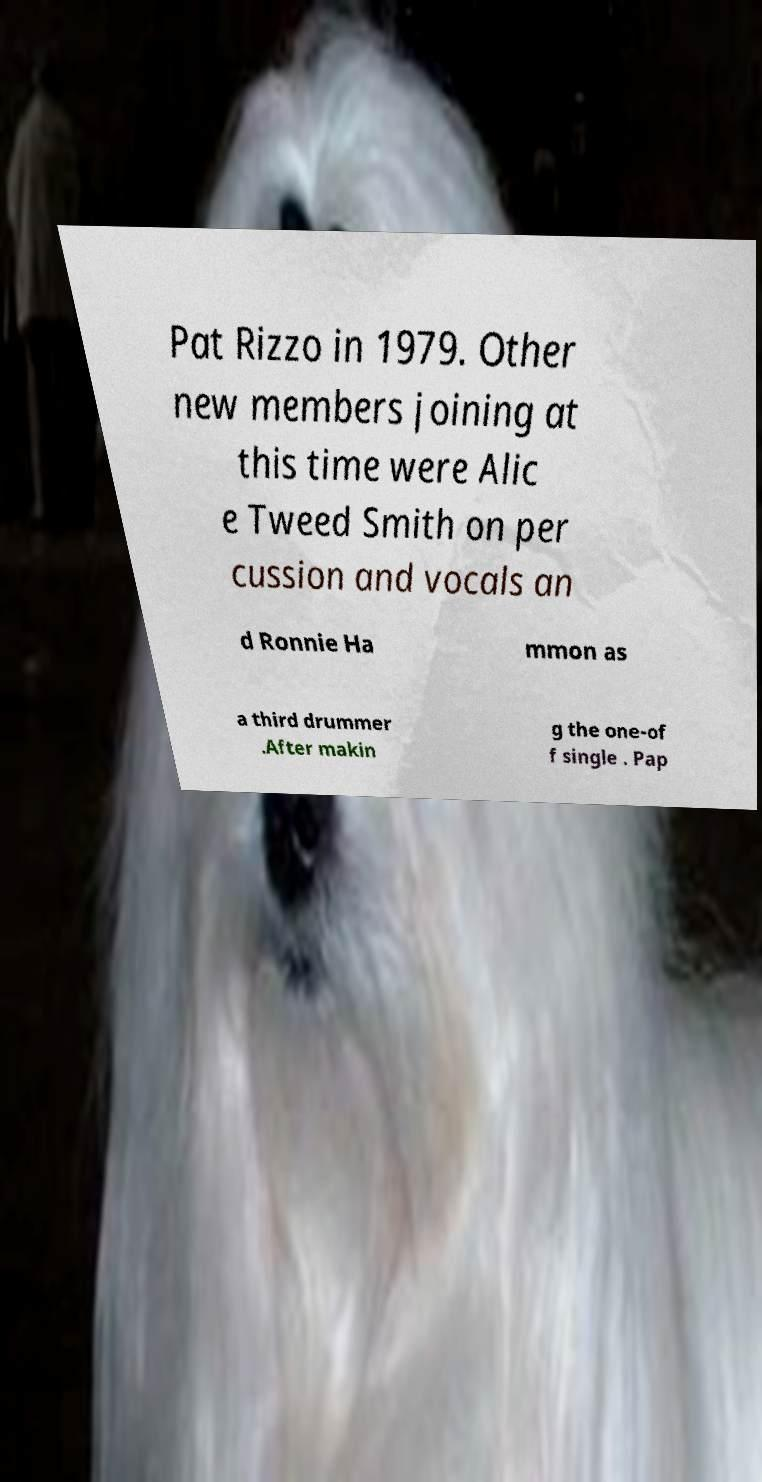I need the written content from this picture converted into text. Can you do that? Pat Rizzo in 1979. Other new members joining at this time were Alic e Tweed Smith on per cussion and vocals an d Ronnie Ha mmon as a third drummer .After makin g the one-of f single . Pap 